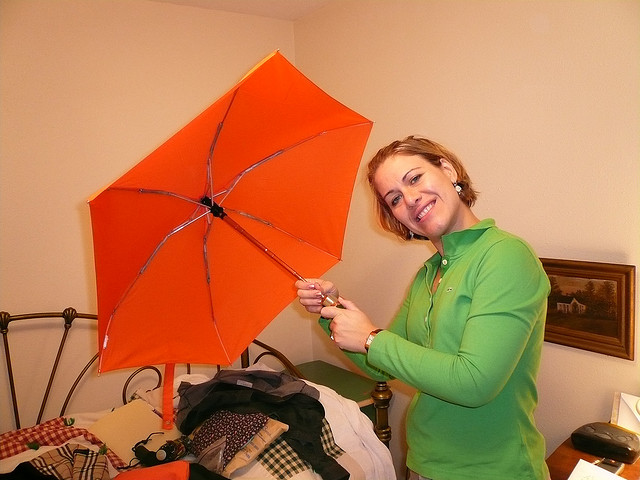<image>What is the white umbrella being used for? There is no white umbrella in the image. What is the white umbrella being used for? There is no white umbrella in the image. 